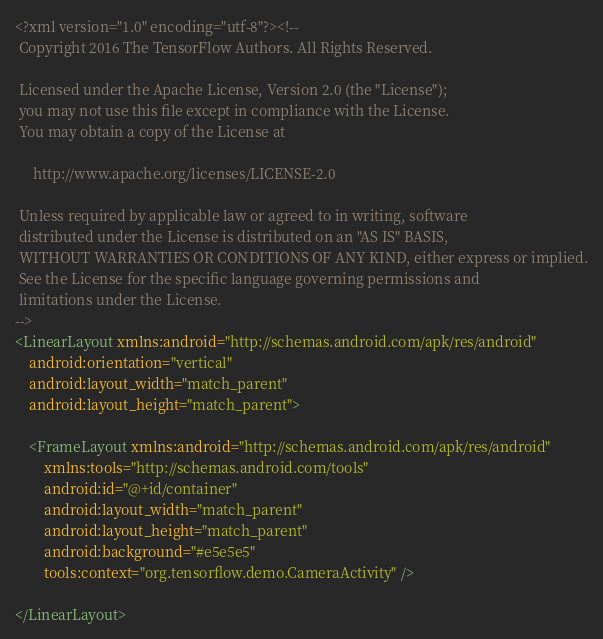Convert code to text. <code><loc_0><loc_0><loc_500><loc_500><_XML_><?xml version="1.0" encoding="utf-8"?><!--
 Copyright 2016 The TensorFlow Authors. All Rights Reserved.

 Licensed under the Apache License, Version 2.0 (the "License");
 you may not use this file except in compliance with the License.
 You may obtain a copy of the License at

     http://www.apache.org/licenses/LICENSE-2.0

 Unless required by applicable law or agreed to in writing, software
 distributed under the License is distributed on an "AS IS" BASIS,
 WITHOUT WARRANTIES OR CONDITIONS OF ANY KIND, either express or implied.
 See the License for the specific language governing permissions and
 limitations under the License.
-->
<LinearLayout xmlns:android="http://schemas.android.com/apk/res/android"
    android:orientation="vertical"
    android:layout_width="match_parent"
    android:layout_height="match_parent">

    <FrameLayout xmlns:android="http://schemas.android.com/apk/res/android"
        xmlns:tools="http://schemas.android.com/tools"
        android:id="@+id/container"
        android:layout_width="match_parent"
        android:layout_height="match_parent"
        android:background="#e5e5e5"
        tools:context="org.tensorflow.demo.CameraActivity" />

</LinearLayout>
</code> 